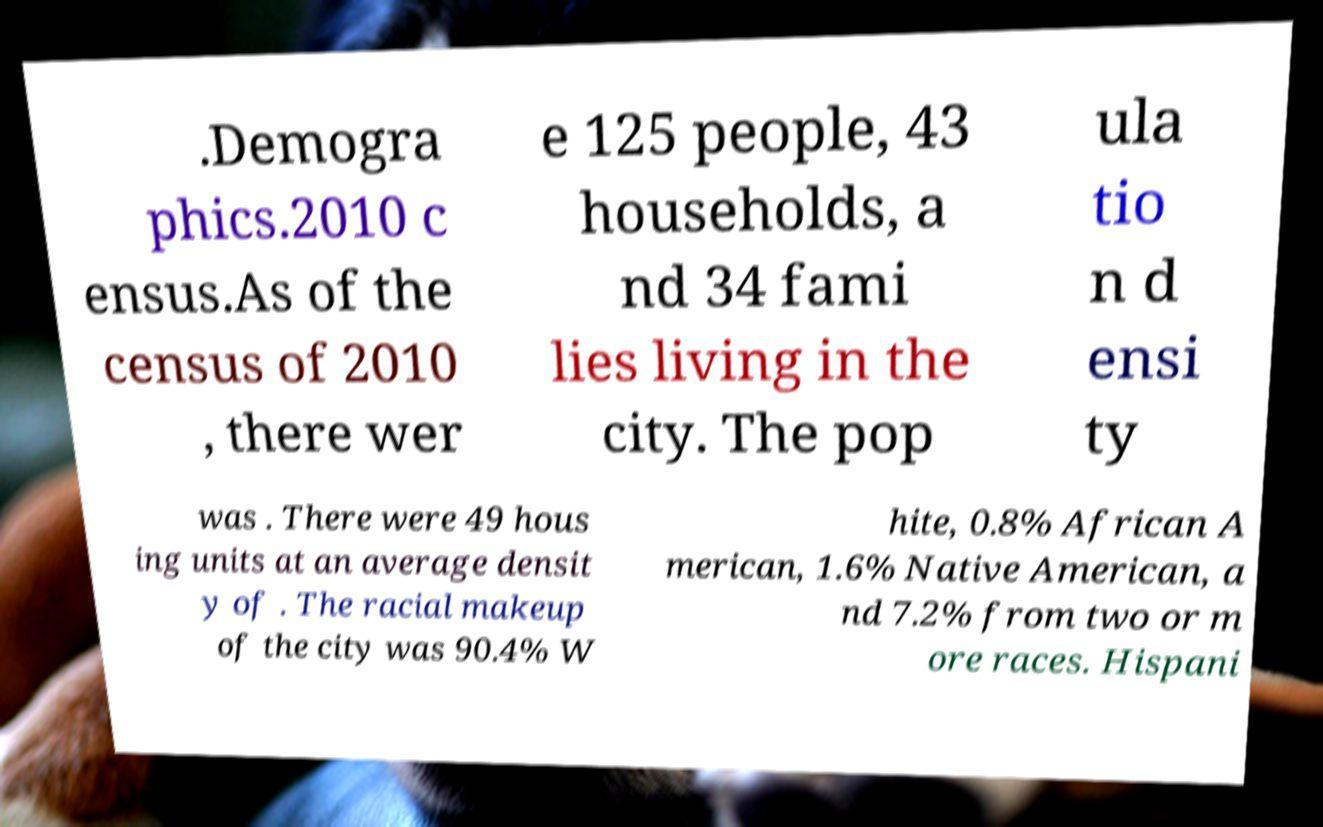Can you accurately transcribe the text from the provided image for me? .Demogra phics.2010 c ensus.As of the census of 2010 , there wer e 125 people, 43 households, a nd 34 fami lies living in the city. The pop ula tio n d ensi ty was . There were 49 hous ing units at an average densit y of . The racial makeup of the city was 90.4% W hite, 0.8% African A merican, 1.6% Native American, a nd 7.2% from two or m ore races. Hispani 